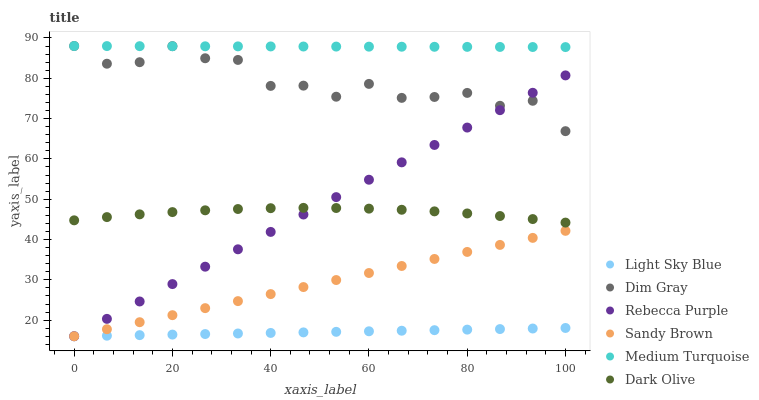Does Light Sky Blue have the minimum area under the curve?
Answer yes or no. Yes. Does Medium Turquoise have the maximum area under the curve?
Answer yes or no. Yes. Does Dark Olive have the minimum area under the curve?
Answer yes or no. No. Does Dark Olive have the maximum area under the curve?
Answer yes or no. No. Is Medium Turquoise the smoothest?
Answer yes or no. Yes. Is Dim Gray the roughest?
Answer yes or no. Yes. Is Dark Olive the smoothest?
Answer yes or no. No. Is Dark Olive the roughest?
Answer yes or no. No. Does Light Sky Blue have the lowest value?
Answer yes or no. Yes. Does Dark Olive have the lowest value?
Answer yes or no. No. Does Medium Turquoise have the highest value?
Answer yes or no. Yes. Does Dark Olive have the highest value?
Answer yes or no. No. Is Sandy Brown less than Dark Olive?
Answer yes or no. Yes. Is Medium Turquoise greater than Light Sky Blue?
Answer yes or no. Yes. Does Rebecca Purple intersect Dim Gray?
Answer yes or no. Yes. Is Rebecca Purple less than Dim Gray?
Answer yes or no. No. Is Rebecca Purple greater than Dim Gray?
Answer yes or no. No. Does Sandy Brown intersect Dark Olive?
Answer yes or no. No. 